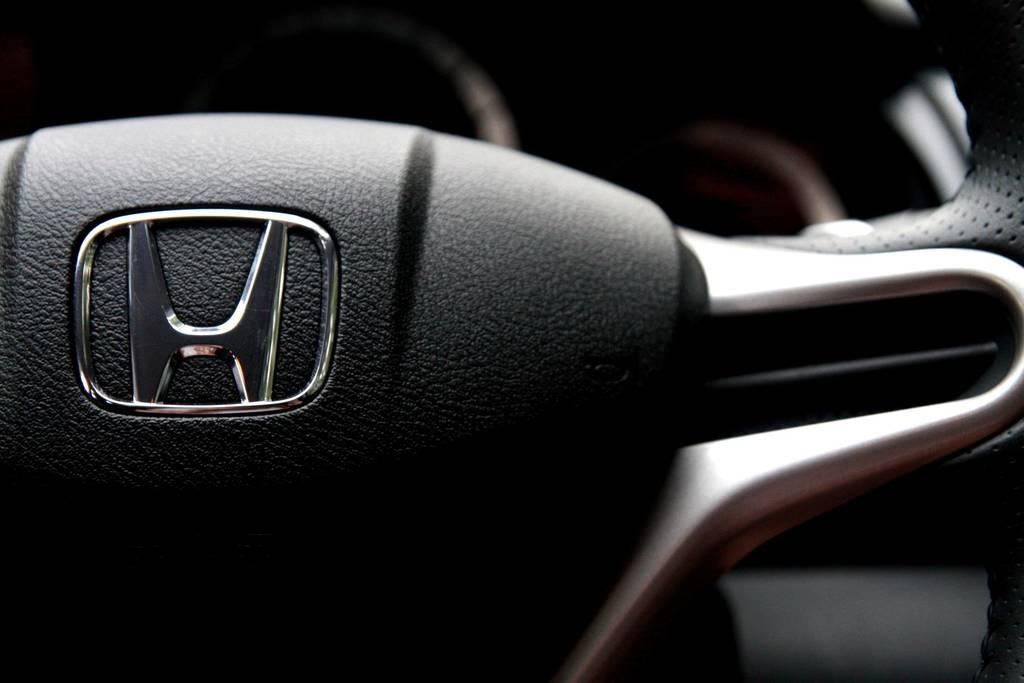What is the setting of the image? The image is of the inside part of a car. What is the main object in the image? There is a steering wheel in the image. What is the color of the steering wheel? The steering wheel is black in color. Can you hear a whistle in the image? There is no whistle present in the image, as it is a still photograph of the inside of a car. 